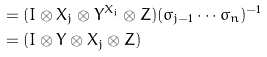Convert formula to latex. <formula><loc_0><loc_0><loc_500><loc_500>& = ( I \otimes X _ { j } \otimes Y ^ { X _ { j } } \otimes Z ) ( \sigma _ { j - 1 } \cdots \sigma _ { n } ) ^ { - 1 } \\ & = ( I \otimes Y \otimes X _ { j } \otimes Z ) \\</formula> 